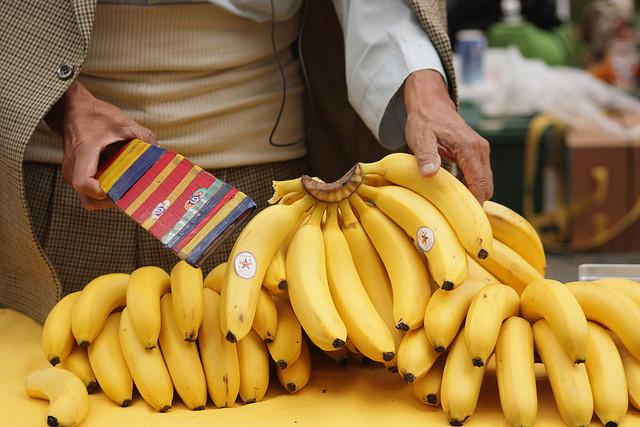How many bananas are there?
Write a very short answer. 35. Are the bananas fresh?
Give a very brief answer. Yes. How many stickers are shown on the fruit?
Write a very short answer. 2. What kind of fruit is this?
Write a very short answer. Bananas. What is the average amount of bananas in each package?
Answer briefly. 12. 